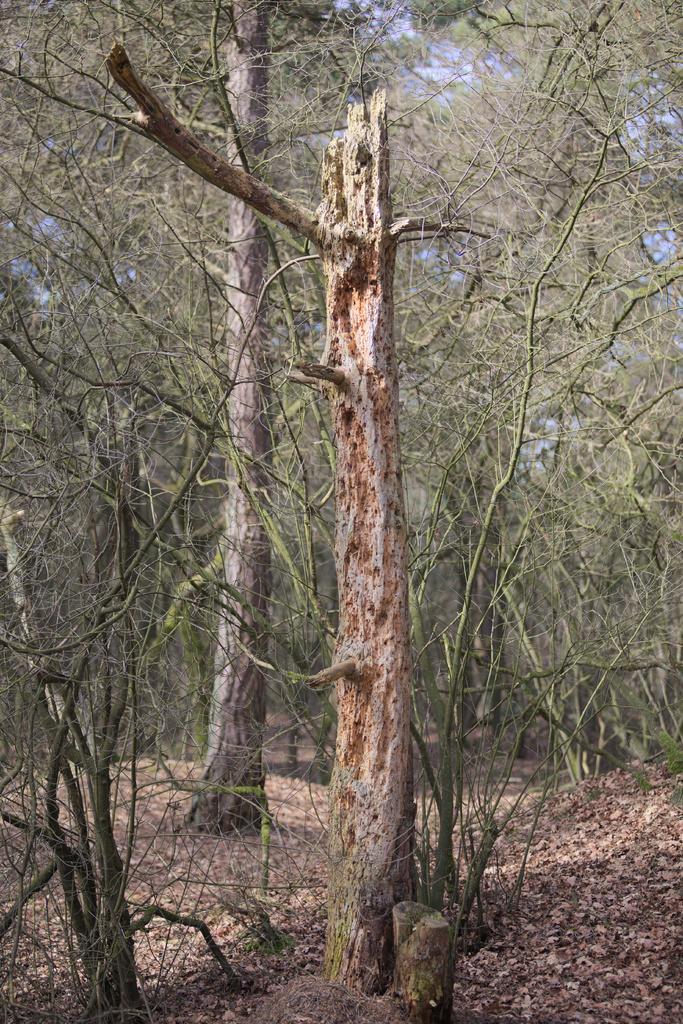In one or two sentences, can you explain what this image depicts? In this picture I can see the ground on which there are number of leaves and I can see number of trees. 